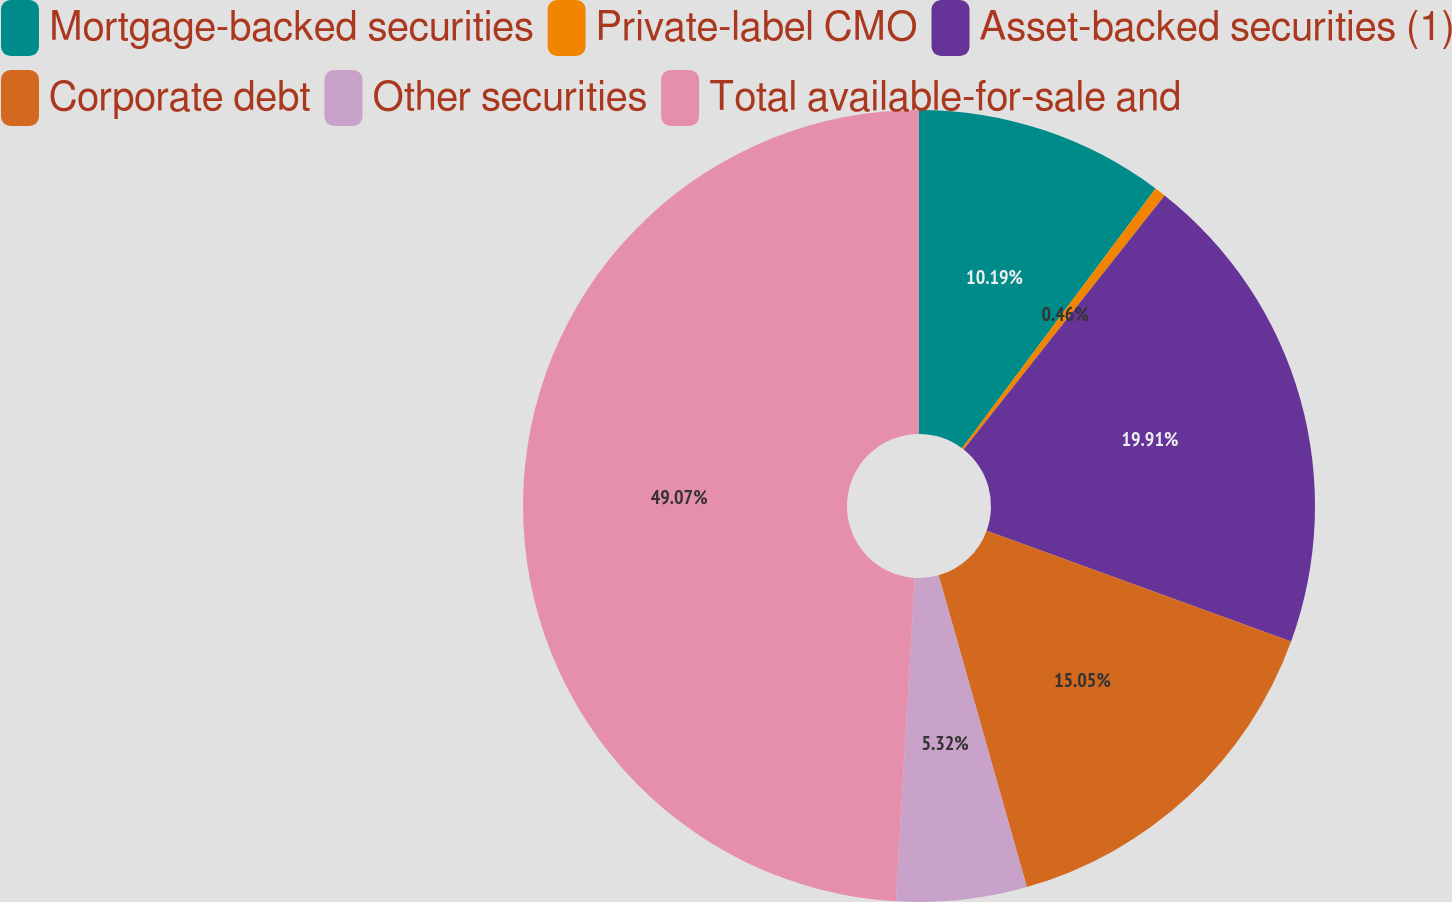Convert chart to OTSL. <chart><loc_0><loc_0><loc_500><loc_500><pie_chart><fcel>Mortgage-backed securities<fcel>Private-label CMO<fcel>Asset-backed securities (1)<fcel>Corporate debt<fcel>Other securities<fcel>Total available-for-sale and<nl><fcel>10.19%<fcel>0.46%<fcel>19.91%<fcel>15.05%<fcel>5.32%<fcel>49.07%<nl></chart> 